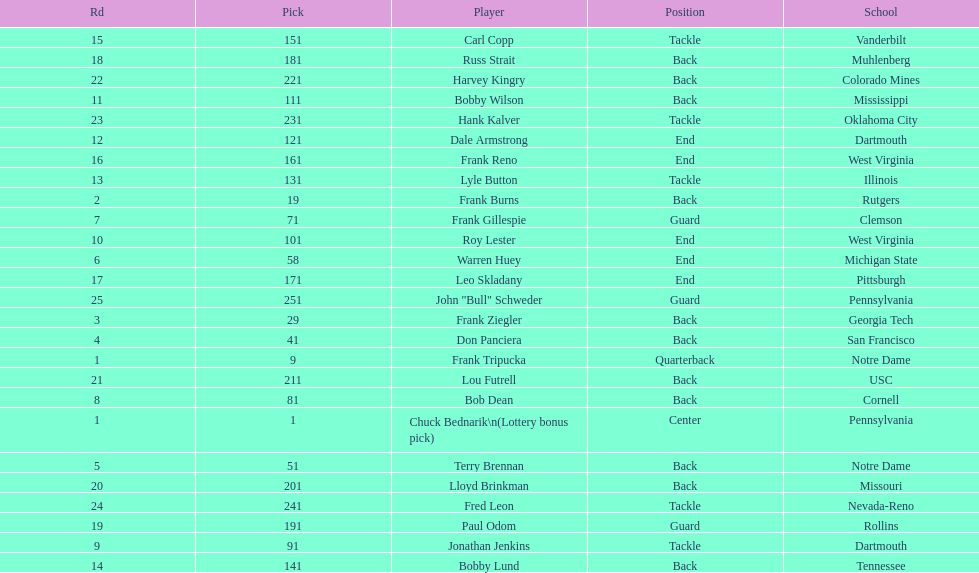Highest rd number? 25. 